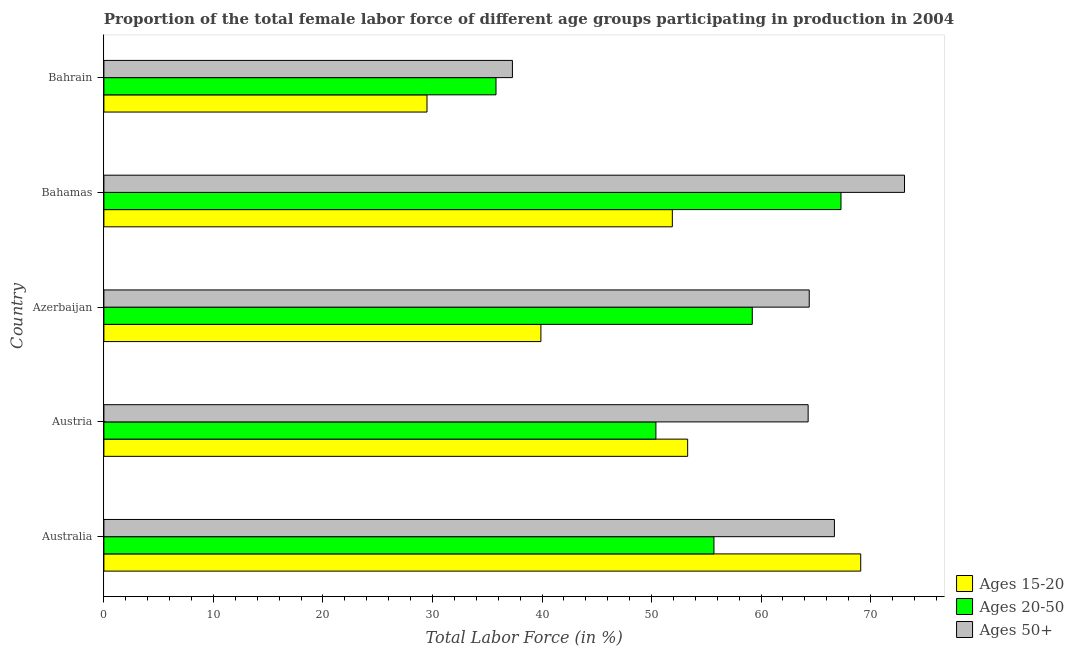How many different coloured bars are there?
Give a very brief answer. 3. Are the number of bars per tick equal to the number of legend labels?
Your response must be concise. Yes. What is the label of the 4th group of bars from the top?
Offer a terse response. Austria. In how many cases, is the number of bars for a given country not equal to the number of legend labels?
Provide a succinct answer. 0. What is the percentage of female labor force above age 50 in Austria?
Keep it short and to the point. 64.3. Across all countries, what is the maximum percentage of female labor force within the age group 20-50?
Provide a succinct answer. 67.3. Across all countries, what is the minimum percentage of female labor force above age 50?
Your answer should be compact. 37.3. In which country was the percentage of female labor force above age 50 maximum?
Provide a short and direct response. Bahamas. In which country was the percentage of female labor force within the age group 15-20 minimum?
Your answer should be compact. Bahrain. What is the total percentage of female labor force within the age group 15-20 in the graph?
Offer a terse response. 243.7. What is the difference between the percentage of female labor force above age 50 in Azerbaijan and that in Bahrain?
Provide a succinct answer. 27.1. What is the difference between the percentage of female labor force above age 50 in Bahrain and the percentage of female labor force within the age group 20-50 in Azerbaijan?
Make the answer very short. -21.9. What is the average percentage of female labor force within the age group 15-20 per country?
Keep it short and to the point. 48.74. What is the difference between the percentage of female labor force above age 50 and percentage of female labor force within the age group 15-20 in Bahamas?
Provide a succinct answer. 21.2. What is the ratio of the percentage of female labor force above age 50 in Azerbaijan to that in Bahrain?
Your answer should be compact. 1.73. Is the percentage of female labor force above age 50 in Austria less than that in Bahrain?
Your answer should be compact. No. Is the difference between the percentage of female labor force within the age group 15-20 in Australia and Azerbaijan greater than the difference between the percentage of female labor force within the age group 20-50 in Australia and Azerbaijan?
Provide a short and direct response. Yes. What is the difference between the highest and the second highest percentage of female labor force within the age group 20-50?
Your answer should be compact. 8.1. What is the difference between the highest and the lowest percentage of female labor force within the age group 20-50?
Offer a very short reply. 31.5. Is the sum of the percentage of female labor force within the age group 15-20 in Azerbaijan and Bahamas greater than the maximum percentage of female labor force within the age group 20-50 across all countries?
Offer a terse response. Yes. What does the 2nd bar from the top in Australia represents?
Offer a very short reply. Ages 20-50. What does the 1st bar from the bottom in Bahamas represents?
Your response must be concise. Ages 15-20. Is it the case that in every country, the sum of the percentage of female labor force within the age group 15-20 and percentage of female labor force within the age group 20-50 is greater than the percentage of female labor force above age 50?
Offer a terse response. Yes. Are all the bars in the graph horizontal?
Offer a very short reply. Yes. What is the difference between two consecutive major ticks on the X-axis?
Offer a very short reply. 10. Are the values on the major ticks of X-axis written in scientific E-notation?
Provide a succinct answer. No. Does the graph contain grids?
Keep it short and to the point. No. How are the legend labels stacked?
Make the answer very short. Vertical. What is the title of the graph?
Your response must be concise. Proportion of the total female labor force of different age groups participating in production in 2004. What is the label or title of the Y-axis?
Provide a short and direct response. Country. What is the Total Labor Force (in %) of Ages 15-20 in Australia?
Offer a terse response. 69.1. What is the Total Labor Force (in %) of Ages 20-50 in Australia?
Your answer should be very brief. 55.7. What is the Total Labor Force (in %) in Ages 50+ in Australia?
Make the answer very short. 66.7. What is the Total Labor Force (in %) of Ages 15-20 in Austria?
Provide a short and direct response. 53.3. What is the Total Labor Force (in %) of Ages 20-50 in Austria?
Ensure brevity in your answer.  50.4. What is the Total Labor Force (in %) of Ages 50+ in Austria?
Your response must be concise. 64.3. What is the Total Labor Force (in %) in Ages 15-20 in Azerbaijan?
Provide a succinct answer. 39.9. What is the Total Labor Force (in %) of Ages 20-50 in Azerbaijan?
Offer a very short reply. 59.2. What is the Total Labor Force (in %) of Ages 50+ in Azerbaijan?
Keep it short and to the point. 64.4. What is the Total Labor Force (in %) of Ages 15-20 in Bahamas?
Make the answer very short. 51.9. What is the Total Labor Force (in %) of Ages 20-50 in Bahamas?
Offer a very short reply. 67.3. What is the Total Labor Force (in %) of Ages 50+ in Bahamas?
Ensure brevity in your answer.  73.1. What is the Total Labor Force (in %) in Ages 15-20 in Bahrain?
Offer a terse response. 29.5. What is the Total Labor Force (in %) of Ages 20-50 in Bahrain?
Offer a terse response. 35.8. What is the Total Labor Force (in %) of Ages 50+ in Bahrain?
Make the answer very short. 37.3. Across all countries, what is the maximum Total Labor Force (in %) of Ages 15-20?
Your answer should be very brief. 69.1. Across all countries, what is the maximum Total Labor Force (in %) of Ages 20-50?
Make the answer very short. 67.3. Across all countries, what is the maximum Total Labor Force (in %) in Ages 50+?
Keep it short and to the point. 73.1. Across all countries, what is the minimum Total Labor Force (in %) of Ages 15-20?
Your response must be concise. 29.5. Across all countries, what is the minimum Total Labor Force (in %) of Ages 20-50?
Ensure brevity in your answer.  35.8. Across all countries, what is the minimum Total Labor Force (in %) in Ages 50+?
Your answer should be very brief. 37.3. What is the total Total Labor Force (in %) in Ages 15-20 in the graph?
Offer a very short reply. 243.7. What is the total Total Labor Force (in %) in Ages 20-50 in the graph?
Keep it short and to the point. 268.4. What is the total Total Labor Force (in %) of Ages 50+ in the graph?
Offer a very short reply. 305.8. What is the difference between the Total Labor Force (in %) of Ages 15-20 in Australia and that in Austria?
Make the answer very short. 15.8. What is the difference between the Total Labor Force (in %) in Ages 50+ in Australia and that in Austria?
Offer a terse response. 2.4. What is the difference between the Total Labor Force (in %) of Ages 15-20 in Australia and that in Azerbaijan?
Ensure brevity in your answer.  29.2. What is the difference between the Total Labor Force (in %) in Ages 15-20 in Australia and that in Bahamas?
Offer a terse response. 17.2. What is the difference between the Total Labor Force (in %) of Ages 50+ in Australia and that in Bahamas?
Provide a succinct answer. -6.4. What is the difference between the Total Labor Force (in %) of Ages 15-20 in Australia and that in Bahrain?
Your response must be concise. 39.6. What is the difference between the Total Labor Force (in %) of Ages 50+ in Australia and that in Bahrain?
Offer a terse response. 29.4. What is the difference between the Total Labor Force (in %) in Ages 15-20 in Austria and that in Azerbaijan?
Offer a terse response. 13.4. What is the difference between the Total Labor Force (in %) in Ages 20-50 in Austria and that in Azerbaijan?
Offer a very short reply. -8.8. What is the difference between the Total Labor Force (in %) in Ages 50+ in Austria and that in Azerbaijan?
Give a very brief answer. -0.1. What is the difference between the Total Labor Force (in %) of Ages 15-20 in Austria and that in Bahamas?
Provide a short and direct response. 1.4. What is the difference between the Total Labor Force (in %) in Ages 20-50 in Austria and that in Bahamas?
Ensure brevity in your answer.  -16.9. What is the difference between the Total Labor Force (in %) of Ages 15-20 in Austria and that in Bahrain?
Ensure brevity in your answer.  23.8. What is the difference between the Total Labor Force (in %) in Ages 50+ in Azerbaijan and that in Bahamas?
Ensure brevity in your answer.  -8.7. What is the difference between the Total Labor Force (in %) in Ages 15-20 in Azerbaijan and that in Bahrain?
Give a very brief answer. 10.4. What is the difference between the Total Labor Force (in %) in Ages 20-50 in Azerbaijan and that in Bahrain?
Your response must be concise. 23.4. What is the difference between the Total Labor Force (in %) of Ages 50+ in Azerbaijan and that in Bahrain?
Give a very brief answer. 27.1. What is the difference between the Total Labor Force (in %) in Ages 15-20 in Bahamas and that in Bahrain?
Ensure brevity in your answer.  22.4. What is the difference between the Total Labor Force (in %) in Ages 20-50 in Bahamas and that in Bahrain?
Your answer should be very brief. 31.5. What is the difference between the Total Labor Force (in %) of Ages 50+ in Bahamas and that in Bahrain?
Offer a very short reply. 35.8. What is the difference between the Total Labor Force (in %) of Ages 15-20 in Australia and the Total Labor Force (in %) of Ages 20-50 in Azerbaijan?
Offer a very short reply. 9.9. What is the difference between the Total Labor Force (in %) in Ages 15-20 in Australia and the Total Labor Force (in %) in Ages 50+ in Azerbaijan?
Make the answer very short. 4.7. What is the difference between the Total Labor Force (in %) in Ages 20-50 in Australia and the Total Labor Force (in %) in Ages 50+ in Azerbaijan?
Your response must be concise. -8.7. What is the difference between the Total Labor Force (in %) of Ages 15-20 in Australia and the Total Labor Force (in %) of Ages 50+ in Bahamas?
Give a very brief answer. -4. What is the difference between the Total Labor Force (in %) of Ages 20-50 in Australia and the Total Labor Force (in %) of Ages 50+ in Bahamas?
Your answer should be very brief. -17.4. What is the difference between the Total Labor Force (in %) of Ages 15-20 in Australia and the Total Labor Force (in %) of Ages 20-50 in Bahrain?
Your answer should be very brief. 33.3. What is the difference between the Total Labor Force (in %) in Ages 15-20 in Australia and the Total Labor Force (in %) in Ages 50+ in Bahrain?
Provide a short and direct response. 31.8. What is the difference between the Total Labor Force (in %) of Ages 15-20 in Austria and the Total Labor Force (in %) of Ages 20-50 in Azerbaijan?
Ensure brevity in your answer.  -5.9. What is the difference between the Total Labor Force (in %) of Ages 15-20 in Austria and the Total Labor Force (in %) of Ages 50+ in Bahamas?
Offer a terse response. -19.8. What is the difference between the Total Labor Force (in %) in Ages 20-50 in Austria and the Total Labor Force (in %) in Ages 50+ in Bahamas?
Keep it short and to the point. -22.7. What is the difference between the Total Labor Force (in %) of Ages 15-20 in Azerbaijan and the Total Labor Force (in %) of Ages 20-50 in Bahamas?
Make the answer very short. -27.4. What is the difference between the Total Labor Force (in %) of Ages 15-20 in Azerbaijan and the Total Labor Force (in %) of Ages 50+ in Bahamas?
Your response must be concise. -33.2. What is the difference between the Total Labor Force (in %) in Ages 15-20 in Azerbaijan and the Total Labor Force (in %) in Ages 20-50 in Bahrain?
Keep it short and to the point. 4.1. What is the difference between the Total Labor Force (in %) in Ages 20-50 in Azerbaijan and the Total Labor Force (in %) in Ages 50+ in Bahrain?
Ensure brevity in your answer.  21.9. What is the difference between the Total Labor Force (in %) in Ages 15-20 in Bahamas and the Total Labor Force (in %) in Ages 50+ in Bahrain?
Keep it short and to the point. 14.6. What is the difference between the Total Labor Force (in %) in Ages 20-50 in Bahamas and the Total Labor Force (in %) in Ages 50+ in Bahrain?
Keep it short and to the point. 30. What is the average Total Labor Force (in %) of Ages 15-20 per country?
Provide a succinct answer. 48.74. What is the average Total Labor Force (in %) in Ages 20-50 per country?
Make the answer very short. 53.68. What is the average Total Labor Force (in %) of Ages 50+ per country?
Provide a short and direct response. 61.16. What is the difference between the Total Labor Force (in %) in Ages 15-20 and Total Labor Force (in %) in Ages 20-50 in Australia?
Keep it short and to the point. 13.4. What is the difference between the Total Labor Force (in %) in Ages 20-50 and Total Labor Force (in %) in Ages 50+ in Australia?
Give a very brief answer. -11. What is the difference between the Total Labor Force (in %) in Ages 15-20 and Total Labor Force (in %) in Ages 20-50 in Austria?
Your answer should be very brief. 2.9. What is the difference between the Total Labor Force (in %) in Ages 15-20 and Total Labor Force (in %) in Ages 20-50 in Azerbaijan?
Keep it short and to the point. -19.3. What is the difference between the Total Labor Force (in %) in Ages 15-20 and Total Labor Force (in %) in Ages 50+ in Azerbaijan?
Keep it short and to the point. -24.5. What is the difference between the Total Labor Force (in %) of Ages 20-50 and Total Labor Force (in %) of Ages 50+ in Azerbaijan?
Make the answer very short. -5.2. What is the difference between the Total Labor Force (in %) of Ages 15-20 and Total Labor Force (in %) of Ages 20-50 in Bahamas?
Your response must be concise. -15.4. What is the difference between the Total Labor Force (in %) of Ages 15-20 and Total Labor Force (in %) of Ages 50+ in Bahamas?
Provide a short and direct response. -21.2. What is the difference between the Total Labor Force (in %) in Ages 20-50 and Total Labor Force (in %) in Ages 50+ in Bahamas?
Offer a terse response. -5.8. What is the ratio of the Total Labor Force (in %) in Ages 15-20 in Australia to that in Austria?
Make the answer very short. 1.3. What is the ratio of the Total Labor Force (in %) of Ages 20-50 in Australia to that in Austria?
Offer a very short reply. 1.11. What is the ratio of the Total Labor Force (in %) in Ages 50+ in Australia to that in Austria?
Ensure brevity in your answer.  1.04. What is the ratio of the Total Labor Force (in %) in Ages 15-20 in Australia to that in Azerbaijan?
Keep it short and to the point. 1.73. What is the ratio of the Total Labor Force (in %) in Ages 20-50 in Australia to that in Azerbaijan?
Give a very brief answer. 0.94. What is the ratio of the Total Labor Force (in %) of Ages 50+ in Australia to that in Azerbaijan?
Ensure brevity in your answer.  1.04. What is the ratio of the Total Labor Force (in %) of Ages 15-20 in Australia to that in Bahamas?
Give a very brief answer. 1.33. What is the ratio of the Total Labor Force (in %) of Ages 20-50 in Australia to that in Bahamas?
Offer a very short reply. 0.83. What is the ratio of the Total Labor Force (in %) of Ages 50+ in Australia to that in Bahamas?
Offer a terse response. 0.91. What is the ratio of the Total Labor Force (in %) of Ages 15-20 in Australia to that in Bahrain?
Give a very brief answer. 2.34. What is the ratio of the Total Labor Force (in %) of Ages 20-50 in Australia to that in Bahrain?
Offer a terse response. 1.56. What is the ratio of the Total Labor Force (in %) in Ages 50+ in Australia to that in Bahrain?
Provide a succinct answer. 1.79. What is the ratio of the Total Labor Force (in %) in Ages 15-20 in Austria to that in Azerbaijan?
Offer a terse response. 1.34. What is the ratio of the Total Labor Force (in %) in Ages 20-50 in Austria to that in Azerbaijan?
Make the answer very short. 0.85. What is the ratio of the Total Labor Force (in %) in Ages 50+ in Austria to that in Azerbaijan?
Ensure brevity in your answer.  1. What is the ratio of the Total Labor Force (in %) of Ages 15-20 in Austria to that in Bahamas?
Make the answer very short. 1.03. What is the ratio of the Total Labor Force (in %) of Ages 20-50 in Austria to that in Bahamas?
Ensure brevity in your answer.  0.75. What is the ratio of the Total Labor Force (in %) in Ages 50+ in Austria to that in Bahamas?
Your response must be concise. 0.88. What is the ratio of the Total Labor Force (in %) of Ages 15-20 in Austria to that in Bahrain?
Your answer should be compact. 1.81. What is the ratio of the Total Labor Force (in %) of Ages 20-50 in Austria to that in Bahrain?
Make the answer very short. 1.41. What is the ratio of the Total Labor Force (in %) in Ages 50+ in Austria to that in Bahrain?
Your response must be concise. 1.72. What is the ratio of the Total Labor Force (in %) in Ages 15-20 in Azerbaijan to that in Bahamas?
Your answer should be compact. 0.77. What is the ratio of the Total Labor Force (in %) in Ages 20-50 in Azerbaijan to that in Bahamas?
Provide a succinct answer. 0.88. What is the ratio of the Total Labor Force (in %) in Ages 50+ in Azerbaijan to that in Bahamas?
Offer a very short reply. 0.88. What is the ratio of the Total Labor Force (in %) in Ages 15-20 in Azerbaijan to that in Bahrain?
Ensure brevity in your answer.  1.35. What is the ratio of the Total Labor Force (in %) of Ages 20-50 in Azerbaijan to that in Bahrain?
Keep it short and to the point. 1.65. What is the ratio of the Total Labor Force (in %) in Ages 50+ in Azerbaijan to that in Bahrain?
Offer a terse response. 1.73. What is the ratio of the Total Labor Force (in %) in Ages 15-20 in Bahamas to that in Bahrain?
Offer a very short reply. 1.76. What is the ratio of the Total Labor Force (in %) in Ages 20-50 in Bahamas to that in Bahrain?
Offer a terse response. 1.88. What is the ratio of the Total Labor Force (in %) in Ages 50+ in Bahamas to that in Bahrain?
Offer a very short reply. 1.96. What is the difference between the highest and the second highest Total Labor Force (in %) in Ages 15-20?
Your answer should be very brief. 15.8. What is the difference between the highest and the second highest Total Labor Force (in %) of Ages 20-50?
Your answer should be very brief. 8.1. What is the difference between the highest and the second highest Total Labor Force (in %) in Ages 50+?
Keep it short and to the point. 6.4. What is the difference between the highest and the lowest Total Labor Force (in %) in Ages 15-20?
Offer a terse response. 39.6. What is the difference between the highest and the lowest Total Labor Force (in %) in Ages 20-50?
Offer a very short reply. 31.5. What is the difference between the highest and the lowest Total Labor Force (in %) of Ages 50+?
Offer a terse response. 35.8. 